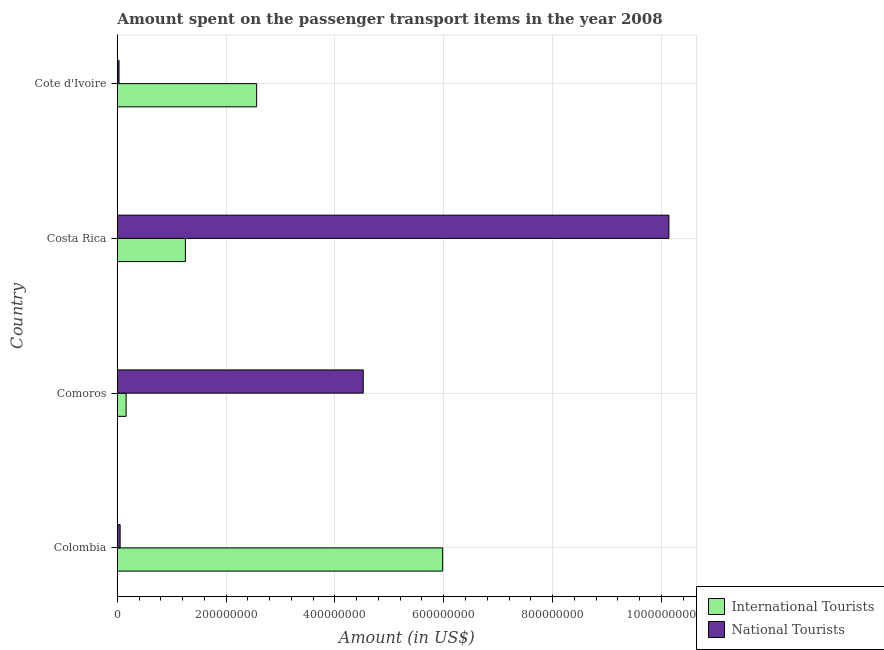How many groups of bars are there?
Ensure brevity in your answer.  4. Are the number of bars per tick equal to the number of legend labels?
Provide a succinct answer. Yes. Are the number of bars on each tick of the Y-axis equal?
Ensure brevity in your answer.  Yes. How many bars are there on the 4th tick from the top?
Your answer should be very brief. 2. How many bars are there on the 3rd tick from the bottom?
Your answer should be very brief. 2. What is the label of the 3rd group of bars from the top?
Ensure brevity in your answer.  Comoros. In how many cases, is the number of bars for a given country not equal to the number of legend labels?
Your answer should be very brief. 0. What is the amount spent on transport items of national tourists in Costa Rica?
Your answer should be compact. 1.01e+09. Across all countries, what is the maximum amount spent on transport items of international tourists?
Make the answer very short. 5.98e+08. Across all countries, what is the minimum amount spent on transport items of international tourists?
Offer a very short reply. 1.60e+07. In which country was the amount spent on transport items of international tourists minimum?
Your answer should be very brief. Comoros. What is the total amount spent on transport items of national tourists in the graph?
Your answer should be very brief. 1.47e+09. What is the difference between the amount spent on transport items of international tourists in Comoros and that in Cote d'Ivoire?
Give a very brief answer. -2.40e+08. What is the difference between the amount spent on transport items of international tourists in Costa Rica and the amount spent on transport items of national tourists in Cote d'Ivoire?
Offer a very short reply. 1.22e+08. What is the average amount spent on transport items of international tourists per country?
Ensure brevity in your answer.  2.49e+08. What is the difference between the amount spent on transport items of national tourists and amount spent on transport items of international tourists in Costa Rica?
Make the answer very short. 8.89e+08. In how many countries, is the amount spent on transport items of international tourists greater than 1000000000 US$?
Ensure brevity in your answer.  0. What is the ratio of the amount spent on transport items of international tourists in Comoros to that in Costa Rica?
Make the answer very short. 0.13. Is the amount spent on transport items of international tourists in Comoros less than that in Costa Rica?
Keep it short and to the point. Yes. What is the difference between the highest and the second highest amount spent on transport items of national tourists?
Provide a succinct answer. 5.62e+08. What is the difference between the highest and the lowest amount spent on transport items of national tourists?
Your answer should be compact. 1.01e+09. Is the sum of the amount spent on transport items of national tourists in Colombia and Costa Rica greater than the maximum amount spent on transport items of international tourists across all countries?
Offer a terse response. Yes. What does the 1st bar from the top in Costa Rica represents?
Provide a short and direct response. National Tourists. What does the 1st bar from the bottom in Cote d'Ivoire represents?
Keep it short and to the point. International Tourists. Are all the bars in the graph horizontal?
Provide a short and direct response. Yes. What is the difference between two consecutive major ticks on the X-axis?
Offer a terse response. 2.00e+08. Are the values on the major ticks of X-axis written in scientific E-notation?
Your answer should be compact. No. Does the graph contain grids?
Give a very brief answer. Yes. Where does the legend appear in the graph?
Give a very brief answer. Bottom right. How many legend labels are there?
Provide a succinct answer. 2. How are the legend labels stacked?
Ensure brevity in your answer.  Vertical. What is the title of the graph?
Your answer should be compact. Amount spent on the passenger transport items in the year 2008. Does "Secondary Education" appear as one of the legend labels in the graph?
Your answer should be very brief. No. What is the Amount (in US$) in International Tourists in Colombia?
Keep it short and to the point. 5.98e+08. What is the Amount (in US$) in National Tourists in Colombia?
Ensure brevity in your answer.  5.00e+06. What is the Amount (in US$) of International Tourists in Comoros?
Give a very brief answer. 1.60e+07. What is the Amount (in US$) of National Tourists in Comoros?
Keep it short and to the point. 4.52e+08. What is the Amount (in US$) in International Tourists in Costa Rica?
Offer a very short reply. 1.25e+08. What is the Amount (in US$) of National Tourists in Costa Rica?
Provide a succinct answer. 1.01e+09. What is the Amount (in US$) in International Tourists in Cote d'Ivoire?
Keep it short and to the point. 2.56e+08. Across all countries, what is the maximum Amount (in US$) in International Tourists?
Provide a succinct answer. 5.98e+08. Across all countries, what is the maximum Amount (in US$) in National Tourists?
Provide a succinct answer. 1.01e+09. Across all countries, what is the minimum Amount (in US$) in International Tourists?
Give a very brief answer. 1.60e+07. Across all countries, what is the minimum Amount (in US$) in National Tourists?
Ensure brevity in your answer.  3.00e+06. What is the total Amount (in US$) of International Tourists in the graph?
Keep it short and to the point. 9.95e+08. What is the total Amount (in US$) of National Tourists in the graph?
Provide a short and direct response. 1.47e+09. What is the difference between the Amount (in US$) in International Tourists in Colombia and that in Comoros?
Offer a terse response. 5.82e+08. What is the difference between the Amount (in US$) of National Tourists in Colombia and that in Comoros?
Keep it short and to the point. -4.47e+08. What is the difference between the Amount (in US$) of International Tourists in Colombia and that in Costa Rica?
Ensure brevity in your answer.  4.73e+08. What is the difference between the Amount (in US$) in National Tourists in Colombia and that in Costa Rica?
Make the answer very short. -1.01e+09. What is the difference between the Amount (in US$) in International Tourists in Colombia and that in Cote d'Ivoire?
Provide a short and direct response. 3.42e+08. What is the difference between the Amount (in US$) of International Tourists in Comoros and that in Costa Rica?
Offer a terse response. -1.09e+08. What is the difference between the Amount (in US$) in National Tourists in Comoros and that in Costa Rica?
Provide a short and direct response. -5.62e+08. What is the difference between the Amount (in US$) of International Tourists in Comoros and that in Cote d'Ivoire?
Offer a very short reply. -2.40e+08. What is the difference between the Amount (in US$) of National Tourists in Comoros and that in Cote d'Ivoire?
Provide a short and direct response. 4.49e+08. What is the difference between the Amount (in US$) in International Tourists in Costa Rica and that in Cote d'Ivoire?
Keep it short and to the point. -1.31e+08. What is the difference between the Amount (in US$) of National Tourists in Costa Rica and that in Cote d'Ivoire?
Ensure brevity in your answer.  1.01e+09. What is the difference between the Amount (in US$) in International Tourists in Colombia and the Amount (in US$) in National Tourists in Comoros?
Your answer should be very brief. 1.46e+08. What is the difference between the Amount (in US$) of International Tourists in Colombia and the Amount (in US$) of National Tourists in Costa Rica?
Your answer should be very brief. -4.16e+08. What is the difference between the Amount (in US$) in International Tourists in Colombia and the Amount (in US$) in National Tourists in Cote d'Ivoire?
Provide a succinct answer. 5.95e+08. What is the difference between the Amount (in US$) in International Tourists in Comoros and the Amount (in US$) in National Tourists in Costa Rica?
Your answer should be very brief. -9.98e+08. What is the difference between the Amount (in US$) of International Tourists in Comoros and the Amount (in US$) of National Tourists in Cote d'Ivoire?
Provide a short and direct response. 1.30e+07. What is the difference between the Amount (in US$) of International Tourists in Costa Rica and the Amount (in US$) of National Tourists in Cote d'Ivoire?
Your answer should be compact. 1.22e+08. What is the average Amount (in US$) in International Tourists per country?
Offer a terse response. 2.49e+08. What is the average Amount (in US$) in National Tourists per country?
Ensure brevity in your answer.  3.68e+08. What is the difference between the Amount (in US$) in International Tourists and Amount (in US$) in National Tourists in Colombia?
Offer a very short reply. 5.93e+08. What is the difference between the Amount (in US$) of International Tourists and Amount (in US$) of National Tourists in Comoros?
Your response must be concise. -4.36e+08. What is the difference between the Amount (in US$) of International Tourists and Amount (in US$) of National Tourists in Costa Rica?
Ensure brevity in your answer.  -8.89e+08. What is the difference between the Amount (in US$) of International Tourists and Amount (in US$) of National Tourists in Cote d'Ivoire?
Ensure brevity in your answer.  2.53e+08. What is the ratio of the Amount (in US$) in International Tourists in Colombia to that in Comoros?
Ensure brevity in your answer.  37.38. What is the ratio of the Amount (in US$) in National Tourists in Colombia to that in Comoros?
Your answer should be compact. 0.01. What is the ratio of the Amount (in US$) in International Tourists in Colombia to that in Costa Rica?
Your answer should be very brief. 4.78. What is the ratio of the Amount (in US$) of National Tourists in Colombia to that in Costa Rica?
Offer a very short reply. 0. What is the ratio of the Amount (in US$) in International Tourists in Colombia to that in Cote d'Ivoire?
Provide a succinct answer. 2.34. What is the ratio of the Amount (in US$) in International Tourists in Comoros to that in Costa Rica?
Ensure brevity in your answer.  0.13. What is the ratio of the Amount (in US$) of National Tourists in Comoros to that in Costa Rica?
Ensure brevity in your answer.  0.45. What is the ratio of the Amount (in US$) in International Tourists in Comoros to that in Cote d'Ivoire?
Offer a terse response. 0.06. What is the ratio of the Amount (in US$) of National Tourists in Comoros to that in Cote d'Ivoire?
Your response must be concise. 150.67. What is the ratio of the Amount (in US$) of International Tourists in Costa Rica to that in Cote d'Ivoire?
Your answer should be compact. 0.49. What is the ratio of the Amount (in US$) of National Tourists in Costa Rica to that in Cote d'Ivoire?
Make the answer very short. 338. What is the difference between the highest and the second highest Amount (in US$) in International Tourists?
Your answer should be compact. 3.42e+08. What is the difference between the highest and the second highest Amount (in US$) in National Tourists?
Make the answer very short. 5.62e+08. What is the difference between the highest and the lowest Amount (in US$) of International Tourists?
Provide a short and direct response. 5.82e+08. What is the difference between the highest and the lowest Amount (in US$) in National Tourists?
Keep it short and to the point. 1.01e+09. 